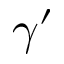<formula> <loc_0><loc_0><loc_500><loc_500>\gamma ^ { \prime }</formula> 